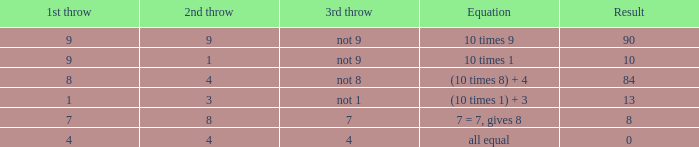Would you be able to parse every entry in this table? {'header': ['1st throw', '2nd throw', '3rd throw', 'Equation', 'Result'], 'rows': [['9', '9', 'not 9', '10 times 9', '90'], ['9', '1', 'not 9', '10 times 1', '10'], ['8', '4', 'not 8', '(10 times 8) + 4', '84'], ['1', '3', 'not 1', '(10 times 1) + 3', '13'], ['7', '8', '7', '7 = 7, gives 8', '8'], ['4', '4', '4', 'all equal', '0']]} What is the result when the 3rd throw is not 8? 84.0. 